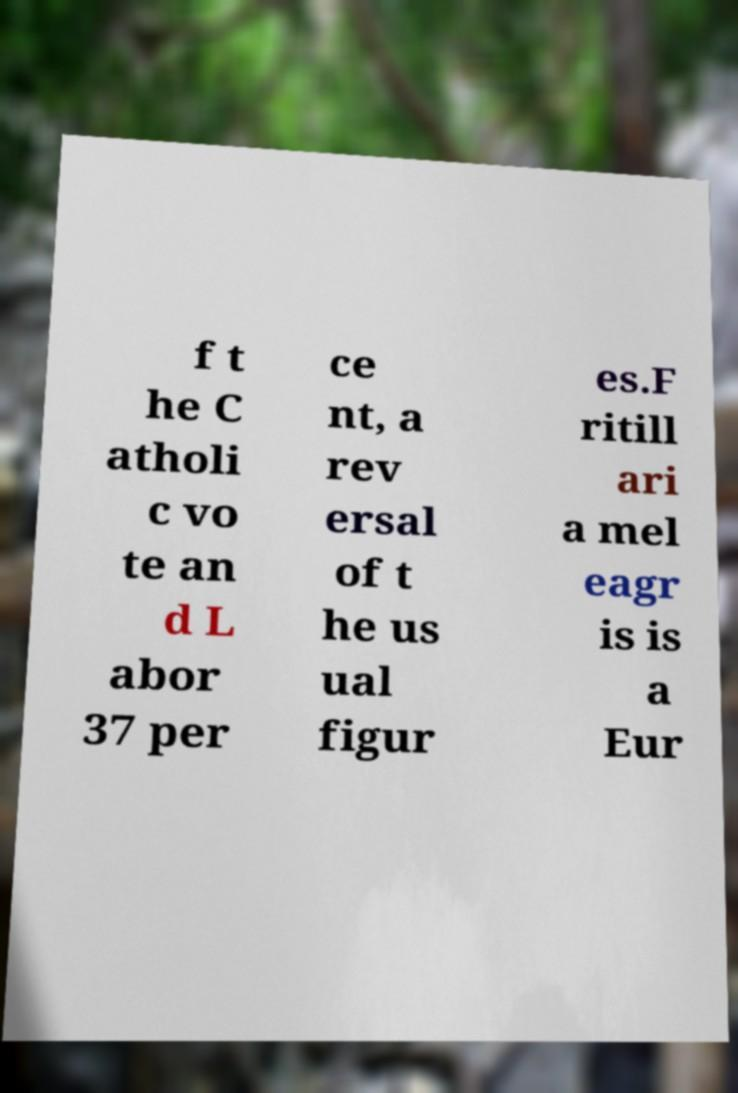What messages or text are displayed in this image? I need them in a readable, typed format. f t he C atholi c vo te an d L abor 37 per ce nt, a rev ersal of t he us ual figur es.F ritill ari a mel eagr is is a Eur 